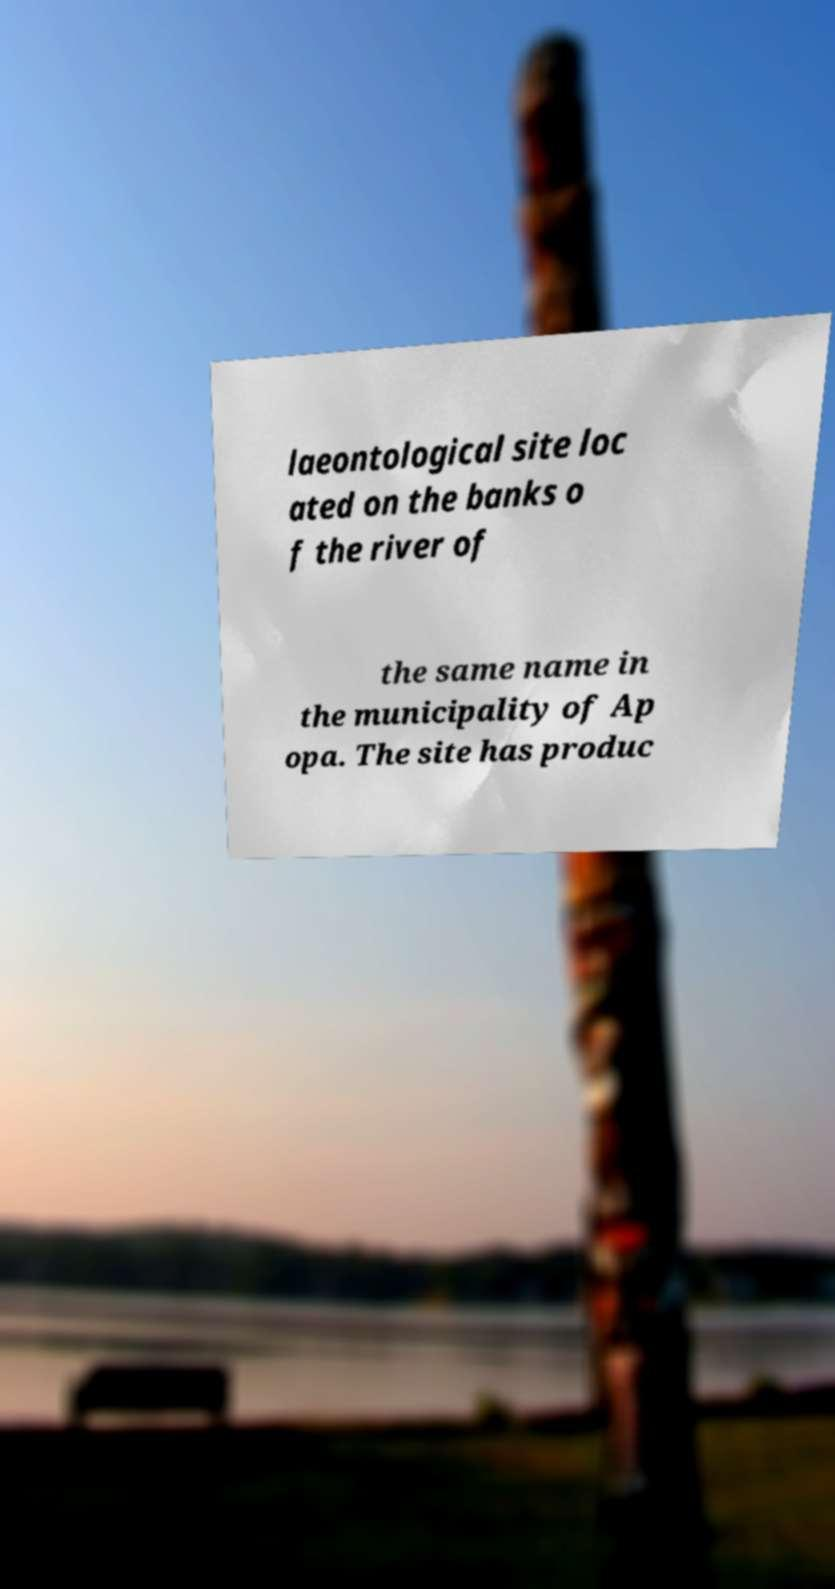Could you extract and type out the text from this image? laeontological site loc ated on the banks o f the river of the same name in the municipality of Ap opa. The site has produc 